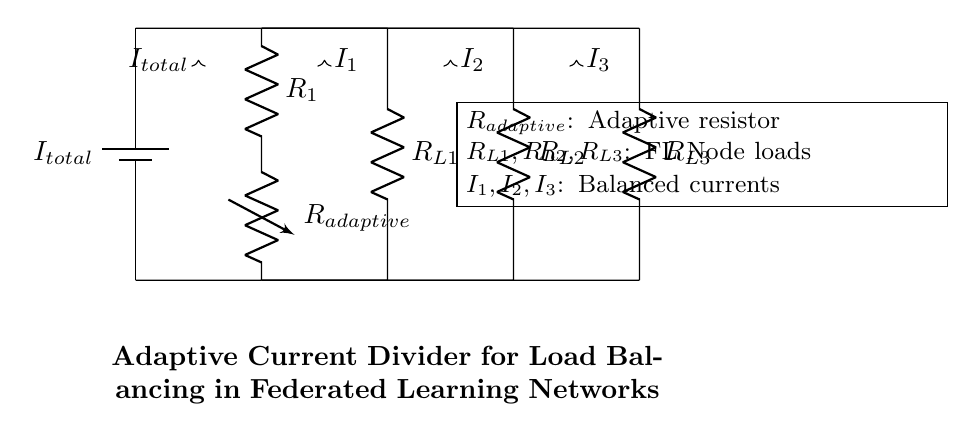What type of circuit is represented here? The circuit depicted is an adaptive current divider, which allows for the distribution of total current to multiple loads based on the resistance of those loads.
Answer: adaptive current divider What is the function of R adaptive? R adaptive is used to adjust the distribution of current among the different load resistances, helping balance the load effectively in the circuit.
Answer: adjust current distribution How many load resistances are in this circuit? There are three load resistances (R L1, R L2, and R L3) connected in parallel to the current divider.
Answer: three What does I total represent? I total represents the total current supplied by the source to the circuit, which is divided among the various load resistances.
Answer: total current If R L1 has a higher resistance than R L2 and R L3, what happens to I1? I1, the current through R L1, will be less compared to I2 and I3, since higher resistance leads to lower current in a parallel circuit.
Answer: less What is the effect of changing the value of R adaptive? Changing the value of R adaptive will alter the current distribution among the three loads, potentially improving load balancing depending on their resistances.
Answer: alters current distribution What relationship exists between the currents I1, I2, and I3? The currents I1, I2, and I3 are inversely related to their respective load resistances, meaning that lower resistance results in higher current.
Answer: inversely related 